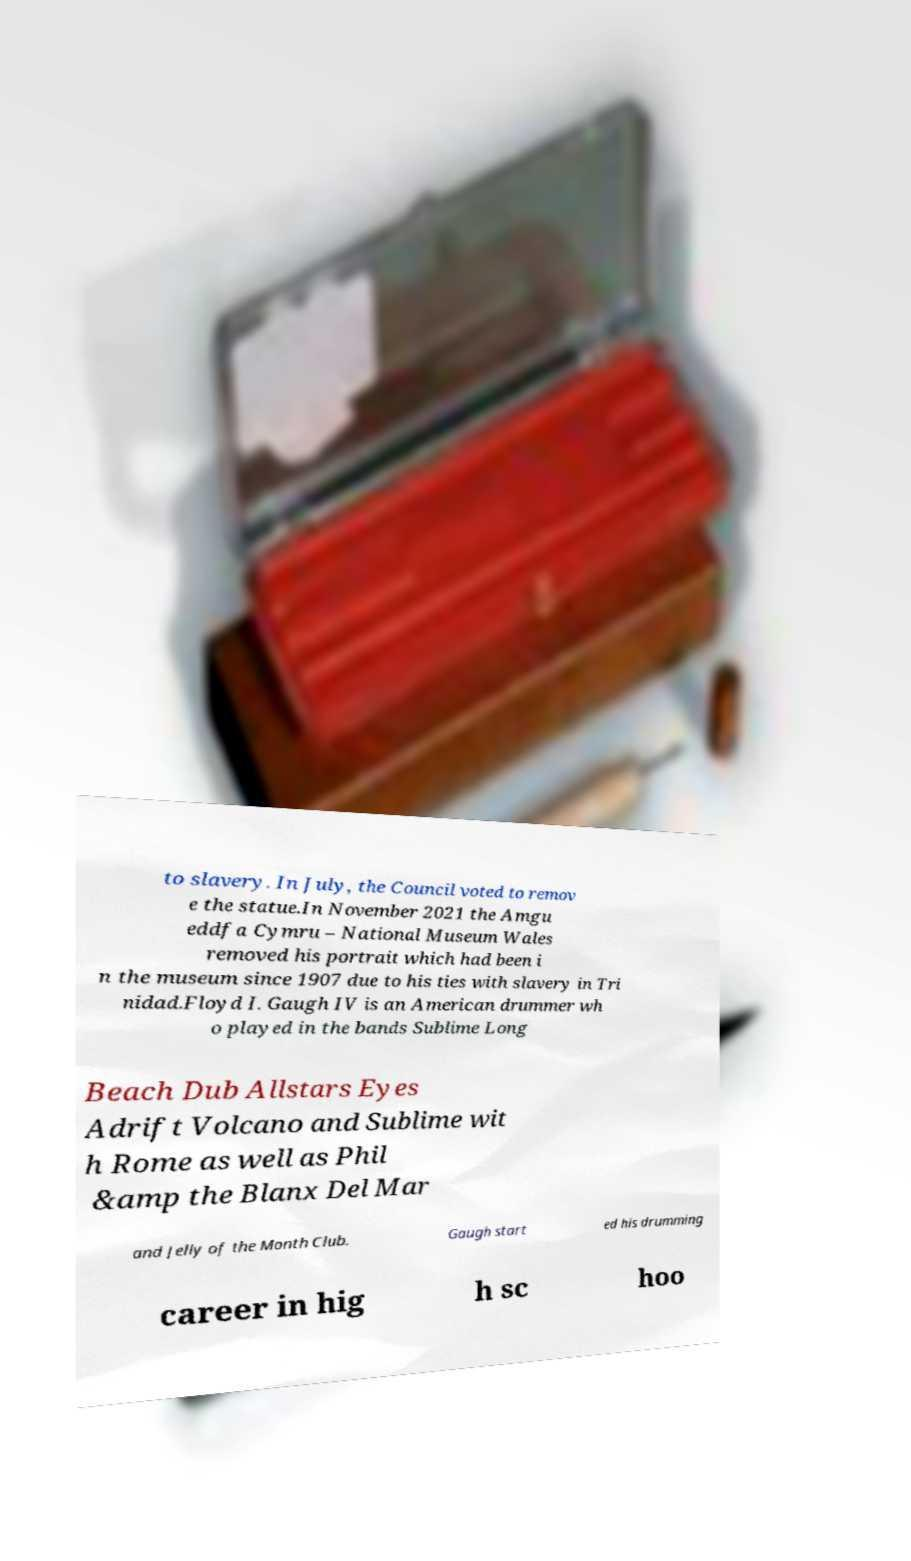Please read and relay the text visible in this image. What does it say? to slavery. In July, the Council voted to remov e the statue.In November 2021 the Amgu eddfa Cymru – National Museum Wales removed his portrait which had been i n the museum since 1907 due to his ties with slavery in Tri nidad.Floyd I. Gaugh IV is an American drummer wh o played in the bands Sublime Long Beach Dub Allstars Eyes Adrift Volcano and Sublime wit h Rome as well as Phil &amp the Blanx Del Mar and Jelly of the Month Club. Gaugh start ed his drumming career in hig h sc hoo 